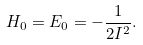Convert formula to latex. <formula><loc_0><loc_0><loc_500><loc_500>H _ { 0 } = E _ { 0 } = - \frac { 1 } { 2 I ^ { 2 } } .</formula> 